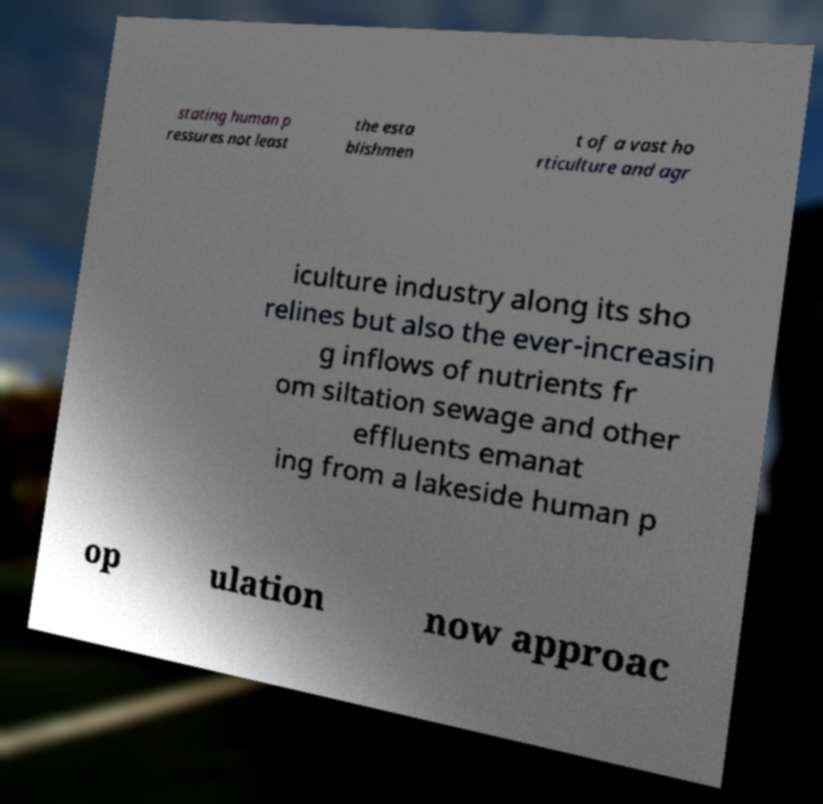There's text embedded in this image that I need extracted. Can you transcribe it verbatim? stating human p ressures not least the esta blishmen t of a vast ho rticulture and agr iculture industry along its sho relines but also the ever-increasin g inflows of nutrients fr om siltation sewage and other effluents emanat ing from a lakeside human p op ulation now approac 